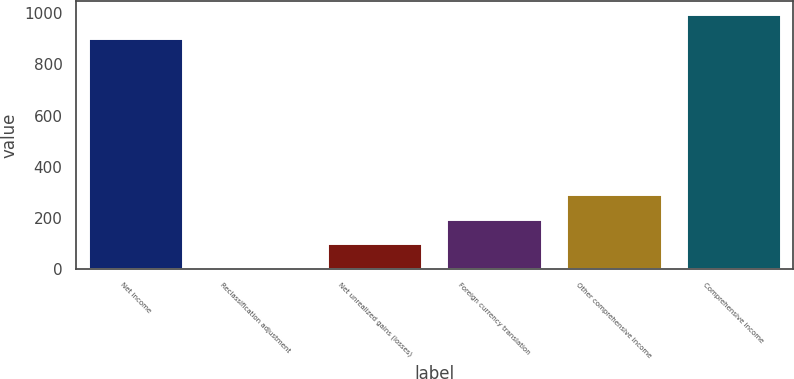Convert chart. <chart><loc_0><loc_0><loc_500><loc_500><bar_chart><fcel>Net income<fcel>Reclassification adjustment<fcel>Net unrealized gains (losses)<fcel>Foreign currency translation<fcel>Other comprehensive income<fcel>Comprehensive income<nl><fcel>902<fcel>3<fcel>99.6<fcel>196.2<fcel>292.8<fcel>998.6<nl></chart> 